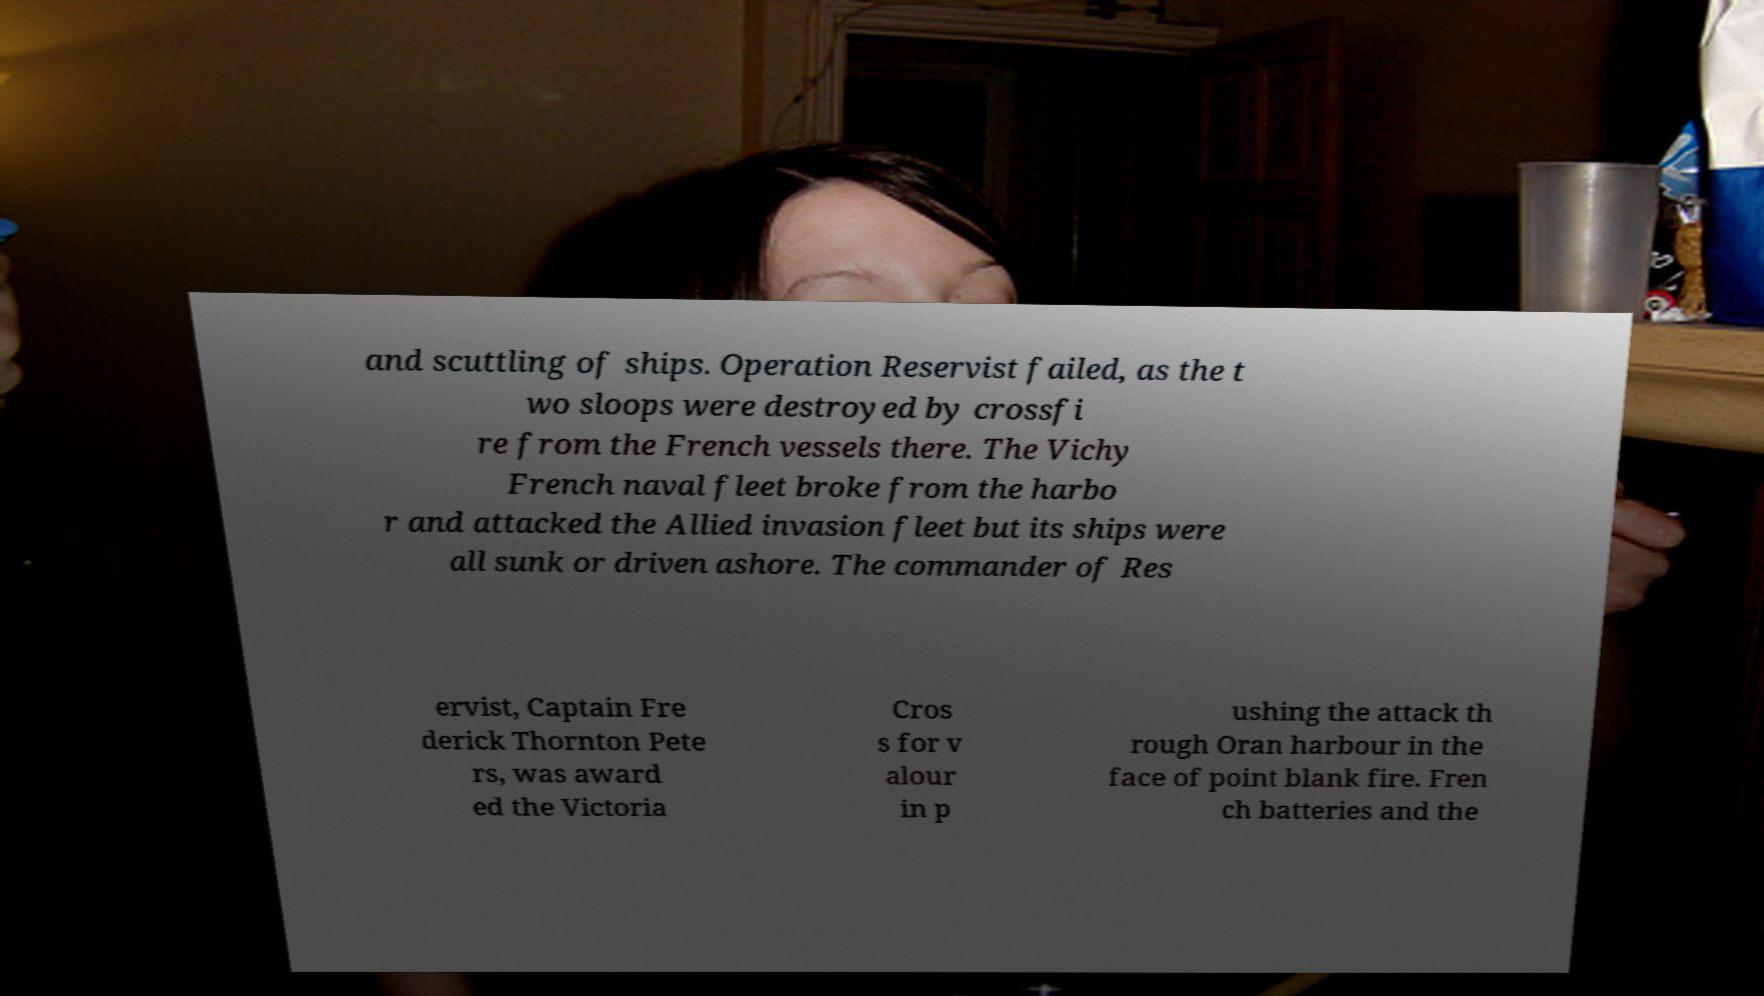What messages or text are displayed in this image? I need them in a readable, typed format. and scuttling of ships. Operation Reservist failed, as the t wo sloops were destroyed by crossfi re from the French vessels there. The Vichy French naval fleet broke from the harbo r and attacked the Allied invasion fleet but its ships were all sunk or driven ashore. The commander of Res ervist, Captain Fre derick Thornton Pete rs, was award ed the Victoria Cros s for v alour in p ushing the attack th rough Oran harbour in the face of point blank fire. Fren ch batteries and the 